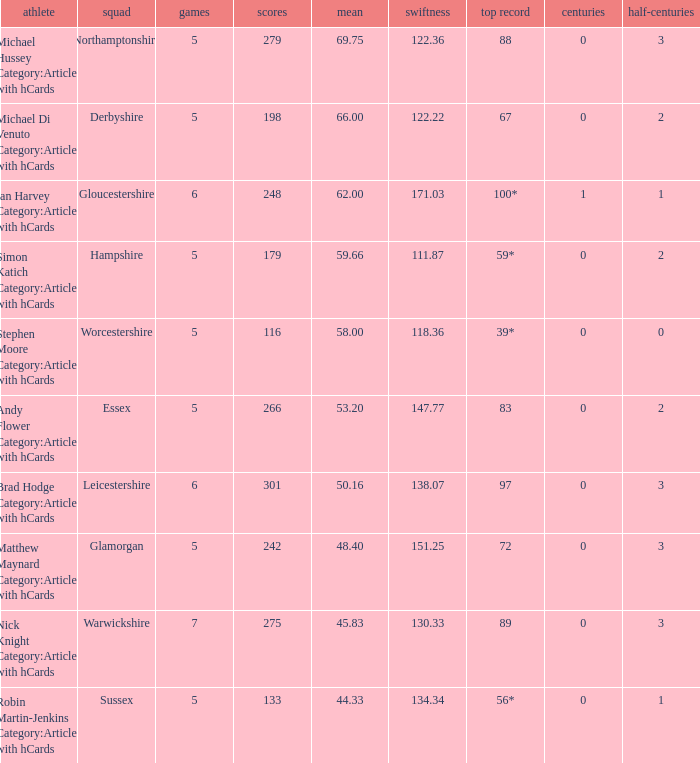If the average is 50.16, who is the player? Brad Hodge Category:Articles with hCards. 